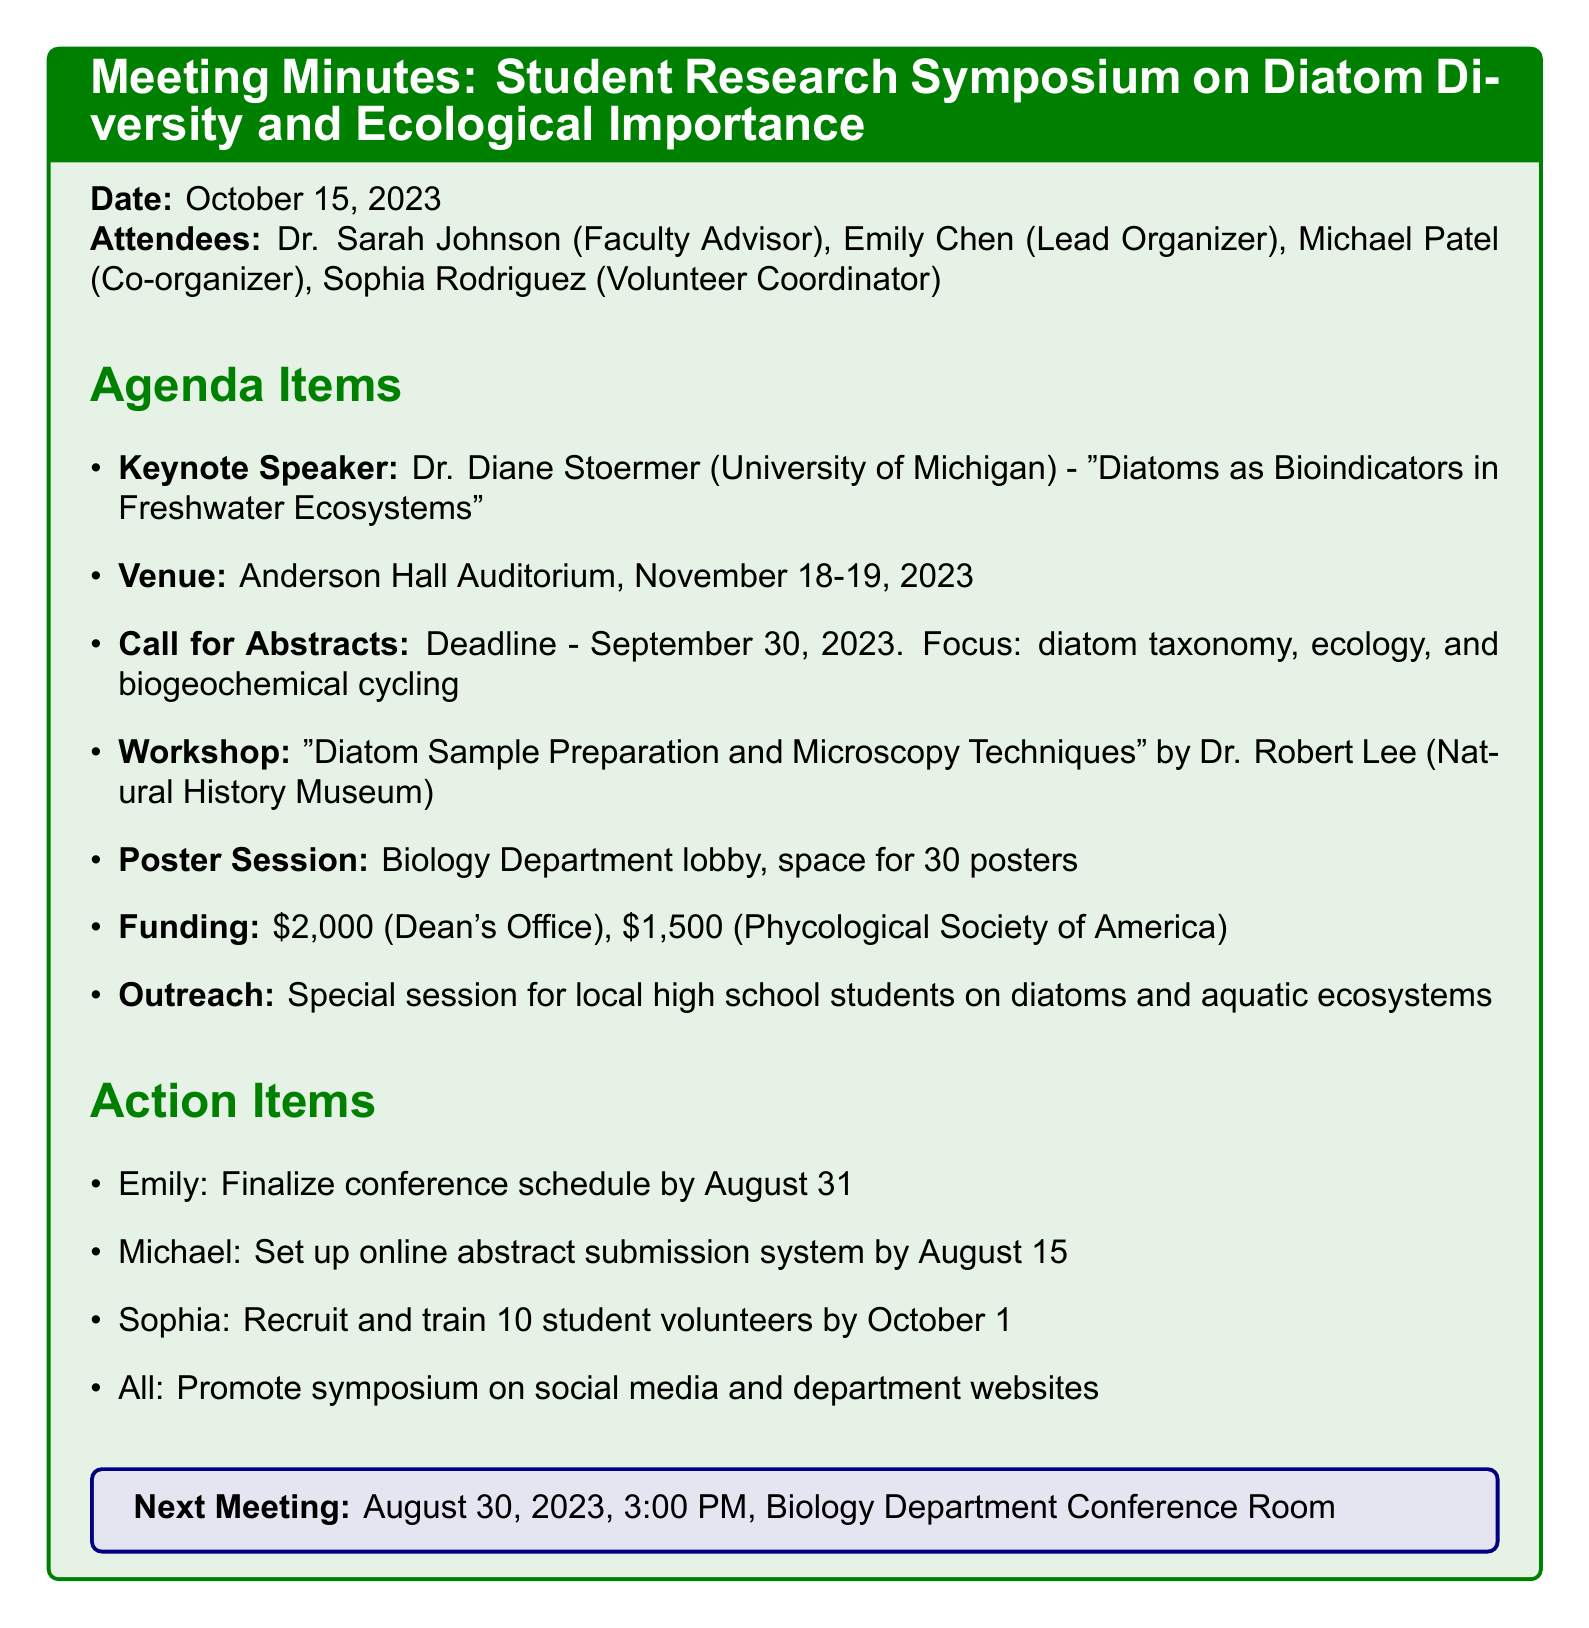What is the date of the meeting? The date of the meeting is listed at the beginning of the document.
Answer: October 15, 2023 Who is the keynote speaker? The document specifies the keynote speaker along with their affiliation and topic.
Answer: Dr. Diane Stoermer What are the conference dates? The document includes the booked venue and the corresponding dates for the symposium.
Answer: November 18-19, 2023 What is the deadline for abstract submissions? The deadline is mentioned clearly under the "Call for Abstracts" section.
Answer: September 30, 2023 How much funding was secured from the Dean's Office? The funding details are listed in a specific agenda item in the document.
Answer: $2,000 What is the focus of the hands-on workshop? The document mentions the topic of the workshop along with the name of the lead.
Answer: Diatom Sample Preparation and Microscopy Techniques How many posters can be accommodated in the poster session? This information is given explicitly under the "Poster Session Logistics" section.
Answer: 30 posters What is the action item for Michael? The action items are listed with assigned individuals and their specific tasks.
Answer: Set up online abstract submission system by August 15 When is the next meeting scheduled? The date and time for the next meeting are noted at the end of the document.
Answer: August 30, 2023, 3:00 PM 